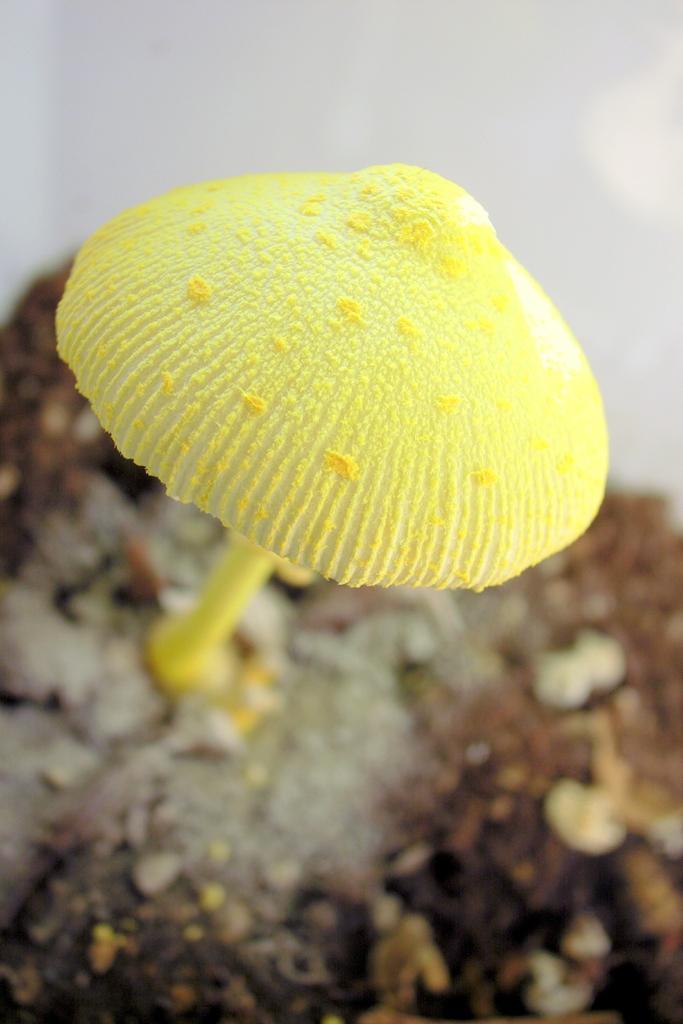How would you summarize this image in a sentence or two? In this image I can see a mushroom in yellow color and I can see blurred background. 